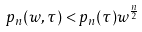<formula> <loc_0><loc_0><loc_500><loc_500>p _ { n } ( w , \tau ) < p _ { n } ( \tau ) w ^ { \frac { n } { 2 } }</formula> 